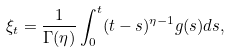<formula> <loc_0><loc_0><loc_500><loc_500>\xi _ { t } = \frac { 1 } { \Gamma ( \eta ) } \int _ { 0 } ^ { t } ( t - s ) ^ { \eta - 1 } g ( s ) d s ,</formula> 